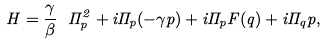Convert formula to latex. <formula><loc_0><loc_0><loc_500><loc_500>H = \frac { \gamma } { \beta } \ \Pi _ { p } ^ { 2 } + i \Pi _ { p } ( - \gamma p ) + i \Pi _ { p } F ( q ) + i \Pi _ { q } p ,</formula> 